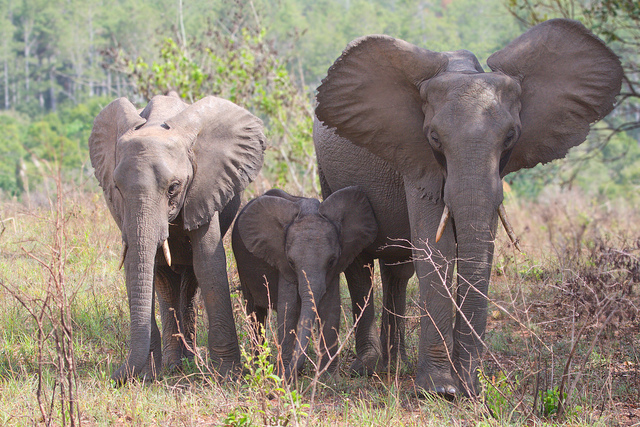Do the elephants in this picture show any signs of their social structure or behavior? Yes, the proximity of the smaller elephants to the adult suggests a tight-knit familial bond, characteristic of elephant herds, where youngsters are closely guarded and nurtured by the adults, especially the matriarch.  What sort of activities might these elephants engage in throughout the day? Elephants typically spend their day foraging for food, which includes grass, leaves, and bark. They also allocate time for social interactions, bathing in water bodies, and resting under the shade of trees during the hottest parts of the day. 